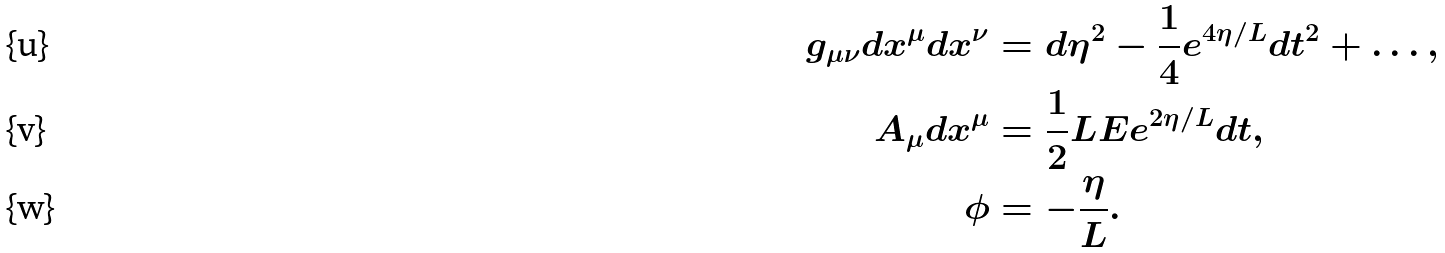<formula> <loc_0><loc_0><loc_500><loc_500>g _ { \mu \nu } d x ^ { \mu } d x ^ { \nu } & = d \eta ^ { 2 } - \frac { 1 } { 4 } e ^ { 4 \eta / L } d t ^ { 2 } + \dots , \\ A _ { \mu } d x ^ { \mu } & = \frac { 1 } { 2 } L E e ^ { 2 \eta / L } d t , \\ \phi & = - \frac { \eta } { L } .</formula> 